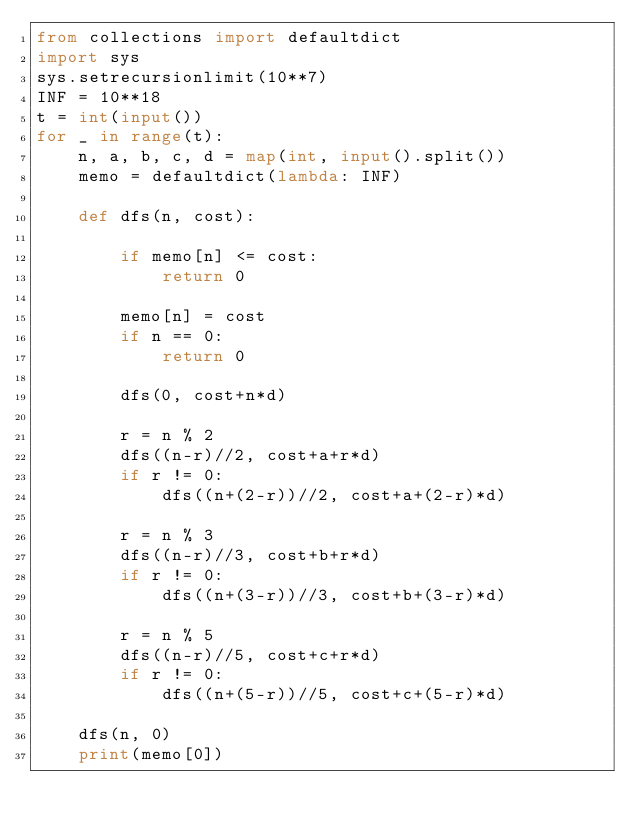<code> <loc_0><loc_0><loc_500><loc_500><_Python_>from collections import defaultdict
import sys
sys.setrecursionlimit(10**7)
INF = 10**18
t = int(input())
for _ in range(t):
    n, a, b, c, d = map(int, input().split())
    memo = defaultdict(lambda: INF)

    def dfs(n, cost):

        if memo[n] <= cost:
            return 0

        memo[n] = cost
        if n == 0:
            return 0

        dfs(0, cost+n*d)

        r = n % 2
        dfs((n-r)//2, cost+a+r*d)
        if r != 0:
            dfs((n+(2-r))//2, cost+a+(2-r)*d)

        r = n % 3
        dfs((n-r)//3, cost+b+r*d)
        if r != 0:
            dfs((n+(3-r))//3, cost+b+(3-r)*d)

        r = n % 5
        dfs((n-r)//5, cost+c+r*d)
        if r != 0:
            dfs((n+(5-r))//5, cost+c+(5-r)*d)
            
    dfs(n, 0)
    print(memo[0])
</code> 